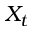<formula> <loc_0><loc_0><loc_500><loc_500>X _ { t }</formula> 